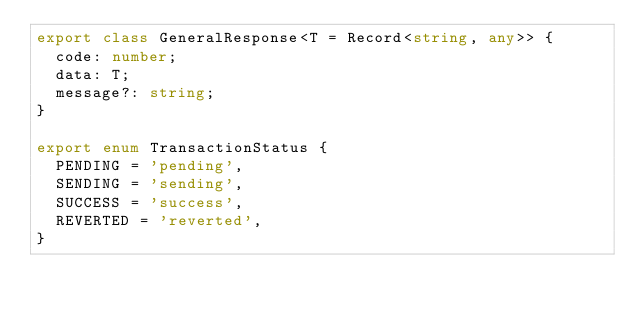<code> <loc_0><loc_0><loc_500><loc_500><_TypeScript_>export class GeneralResponse<T = Record<string, any>> {
  code: number;
  data: T;
  message?: string;
}

export enum TransactionStatus {
  PENDING = 'pending',
  SENDING = 'sending',
  SUCCESS = 'success',
  REVERTED = 'reverted',
}
</code> 